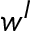<formula> <loc_0><loc_0><loc_500><loc_500>w ^ { I }</formula> 